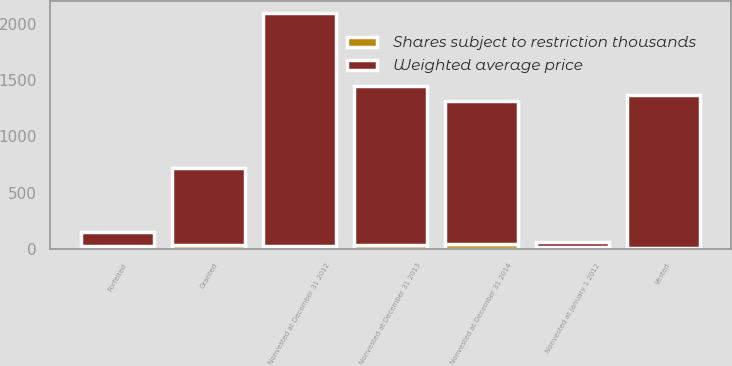Convert chart to OTSL. <chart><loc_0><loc_0><loc_500><loc_500><stacked_bar_chart><ecel><fcel>Nonvested at January 1 2012<fcel>Granted<fcel>Vested<fcel>Forfeited<fcel>Nonvested at December 31 2012<fcel>Nonvested at December 31 2013<fcel>Nonvested at December 31 2014<nl><fcel>Weighted average price<fcel>43.57<fcel>676<fcel>1350<fcel>122<fcel>2064<fcel>1411<fcel>1266<nl><fcel>Shares subject to restriction thousands<fcel>19.51<fcel>39.21<fcel>13.72<fcel>27.18<fcel>29.39<fcel>37.86<fcel>43.57<nl></chart> 